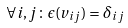Convert formula to latex. <formula><loc_0><loc_0><loc_500><loc_500>\forall i , j \colon \epsilon ( v _ { i j } ) = \delta _ { i j }</formula> 